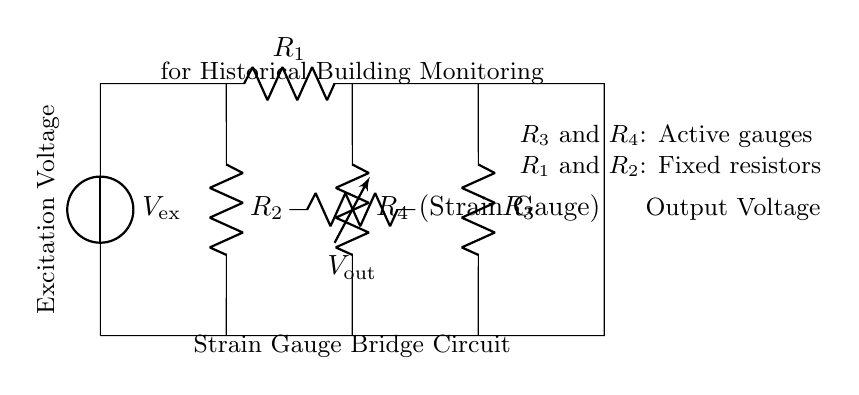What is the excitation voltage in the circuit? The excitation voltage is the voltage supplied to the circuit, identified by the label V_ex on the voltage source in the diagram.
Answer: V_ex How many resistors are present in the circuit? The circuit contains a total of four resistors: R_1, R_2, R_3, and R_4, as indicated by the labels next to each of the resistive components.
Answer: 4 What type of gauge is represented by R_4? R_4 is labeled as a strain gauge, which is specifically used to measure deformation or strain in the structure being monitored.
Answer: Strain Gauge Which resistors are designated as active gauges? The active gauges are identified as R_3 and R_4 in the diagram, noted by the annotations accompanying these resistors.
Answer: R_3 and R_4 How does the output voltage relate to the strain gauge? The output voltage, labeled V_out, is influenced by the change in resistance of the strain gauge (R_4) in relation to the fixed resistors (R_1 and R_2), allowing it to provide a measurement of structural integrity.
Answer: Changes in resistance What is the purpose of R_1 and R_2 in the circuit? R_1 and R_2 serve as fixed resistors that provide a stable reference for the output voltage measurement, ensuring the bridge remains balanced under normal conditions.
Answer: Stabilizing reference What happens if the strain gauge (R_4) experiences significant deformation? If R_4 experiences significant deformation, its resistance will change, leading to a variation in V_out, which indicates a potential structural issue that needs to be addressed.
Answer: Variation in output voltage 